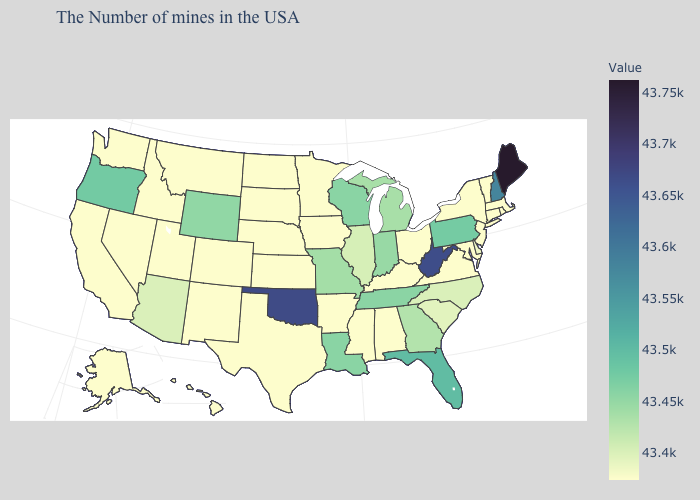Does Kentucky have the lowest value in the South?
Concise answer only. Yes. Among the states that border Illinois , which have the highest value?
Be succinct. Wisconsin. Does Oklahoma have a higher value than Delaware?
Concise answer only. Yes. Does Wisconsin have the lowest value in the USA?
Short answer required. No. Is the legend a continuous bar?
Give a very brief answer. Yes. Which states have the lowest value in the West?
Concise answer only. Colorado, New Mexico, Utah, Montana, Idaho, Nevada, California, Washington, Alaska, Hawaii. Which states hav the highest value in the MidWest?
Write a very short answer. Wisconsin. Among the states that border Virginia , does West Virginia have the highest value?
Short answer required. Yes. Does Montana have a lower value than Florida?
Keep it brief. Yes. 